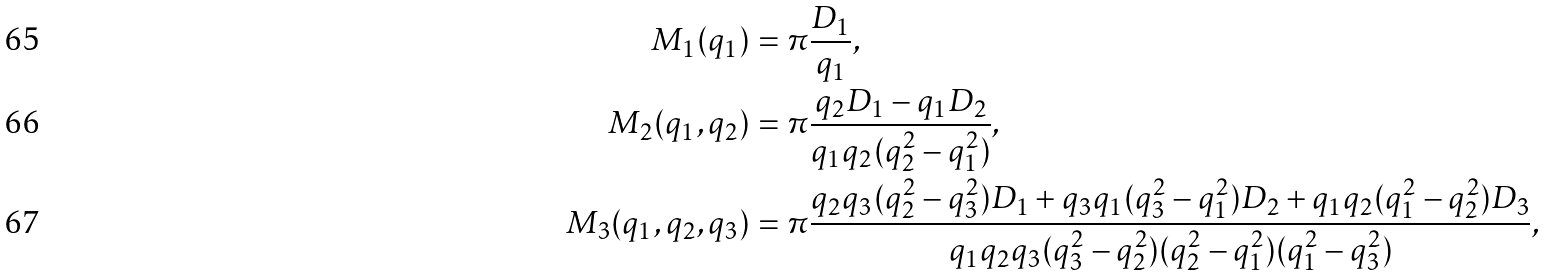<formula> <loc_0><loc_0><loc_500><loc_500>M _ { 1 } ( q _ { 1 } ) & = \pi \frac { D _ { 1 } } { q _ { 1 } } , \\ M _ { 2 } ( q _ { 1 } , q _ { 2 } ) & = \pi \frac { q _ { 2 } D _ { 1 } - q _ { 1 } D _ { 2 } } { q _ { 1 } q _ { 2 } ( q _ { 2 } ^ { 2 } - q _ { 1 } ^ { 2 } ) } , \\ M _ { 3 } ( q _ { 1 } , q _ { 2 } , q _ { 3 } ) & = \pi \frac { q _ { 2 } q _ { 3 } ( q _ { 2 } ^ { 2 } - q _ { 3 } ^ { 2 } ) D _ { 1 } + q _ { 3 } q _ { 1 } ( q _ { 3 } ^ { 2 } - q _ { 1 } ^ { 2 } ) D _ { 2 } + q _ { 1 } q _ { 2 } ( q _ { 1 } ^ { 2 } - q _ { 2 } ^ { 2 } ) D _ { 3 } } { q _ { 1 } q _ { 2 } q _ { 3 } ( q _ { 3 } ^ { 2 } - q _ { 2 } ^ { 2 } ) ( q _ { 2 } ^ { 2 } - q _ { 1 } ^ { 2 } ) ( q _ { 1 } ^ { 2 } - q _ { 3 } ^ { 2 } ) } ,</formula> 